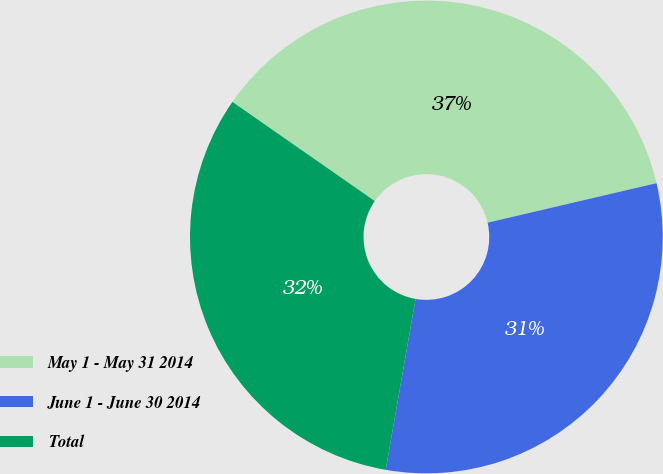<chart> <loc_0><loc_0><loc_500><loc_500><pie_chart><fcel>May 1 - May 31 2014<fcel>June 1 - June 30 2014<fcel>Total<nl><fcel>36.66%<fcel>31.41%<fcel>31.93%<nl></chart> 